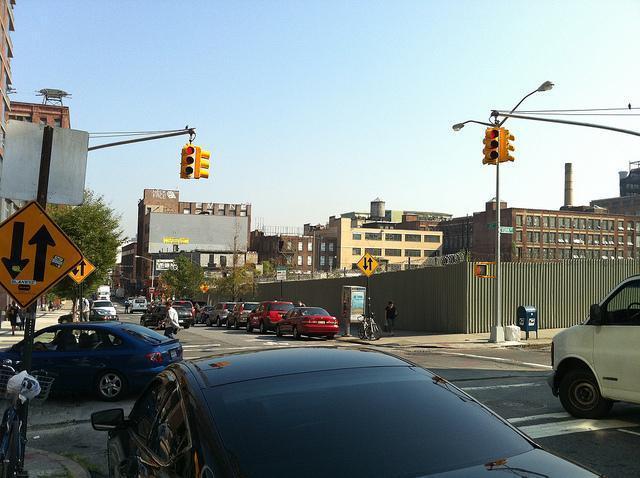How many cars are in the picture?
Give a very brief answer. 3. 